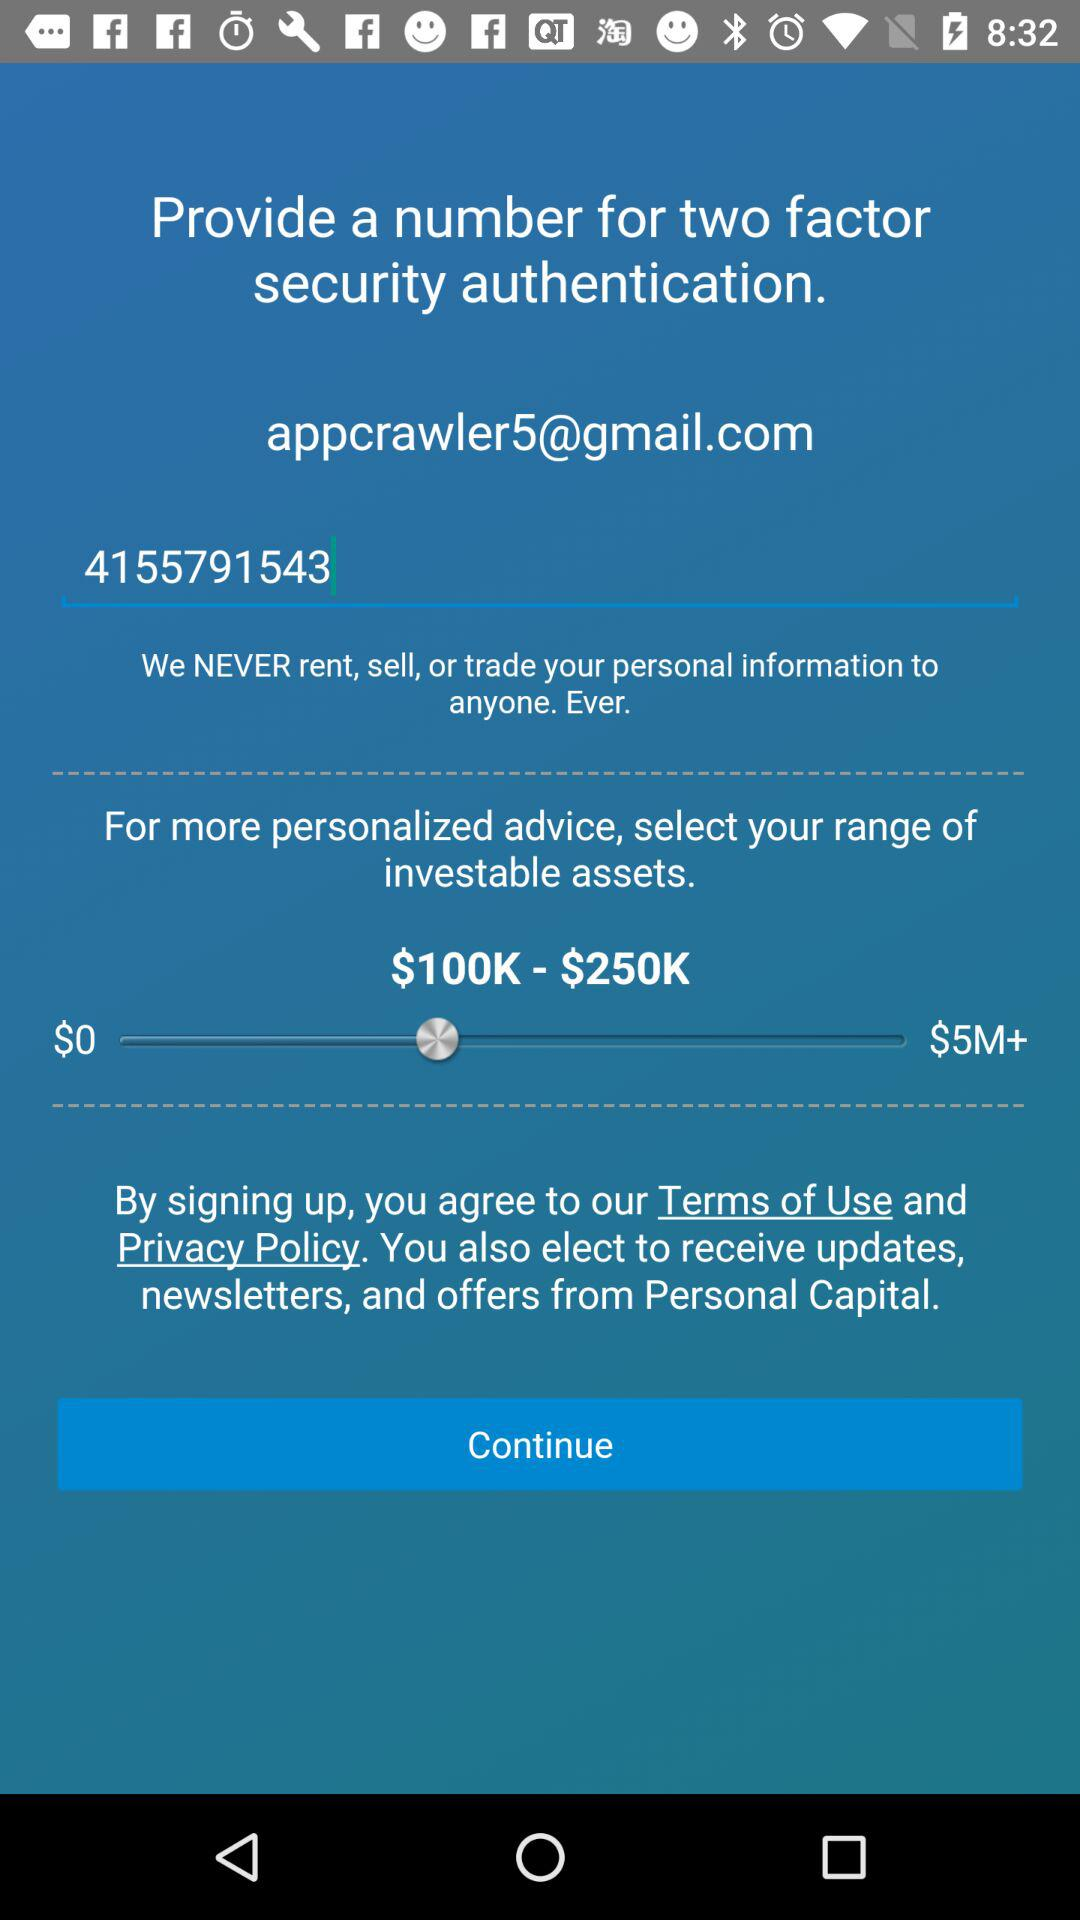What is the email address for two-factor security authentication? The email address is appcrawler5@gmail.com. 